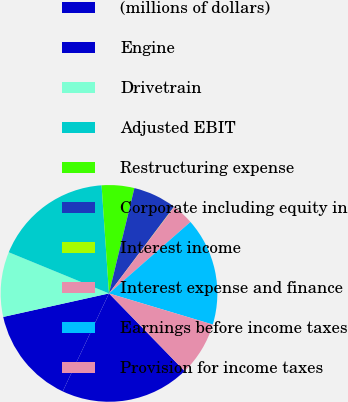<chart> <loc_0><loc_0><loc_500><loc_500><pie_chart><fcel>(millions of dollars)<fcel>Engine<fcel>Drivetrain<fcel>Adjusted EBIT<fcel>Restructuring expense<fcel>Corporate including equity in<fcel>Interest income<fcel>Interest expense and finance<fcel>Earnings before income taxes<fcel>Provision for income taxes<nl><fcel>19.31%<fcel>14.5%<fcel>9.68%<fcel>17.71%<fcel>4.86%<fcel>6.47%<fcel>0.04%<fcel>3.26%<fcel>16.1%<fcel>8.07%<nl></chart> 